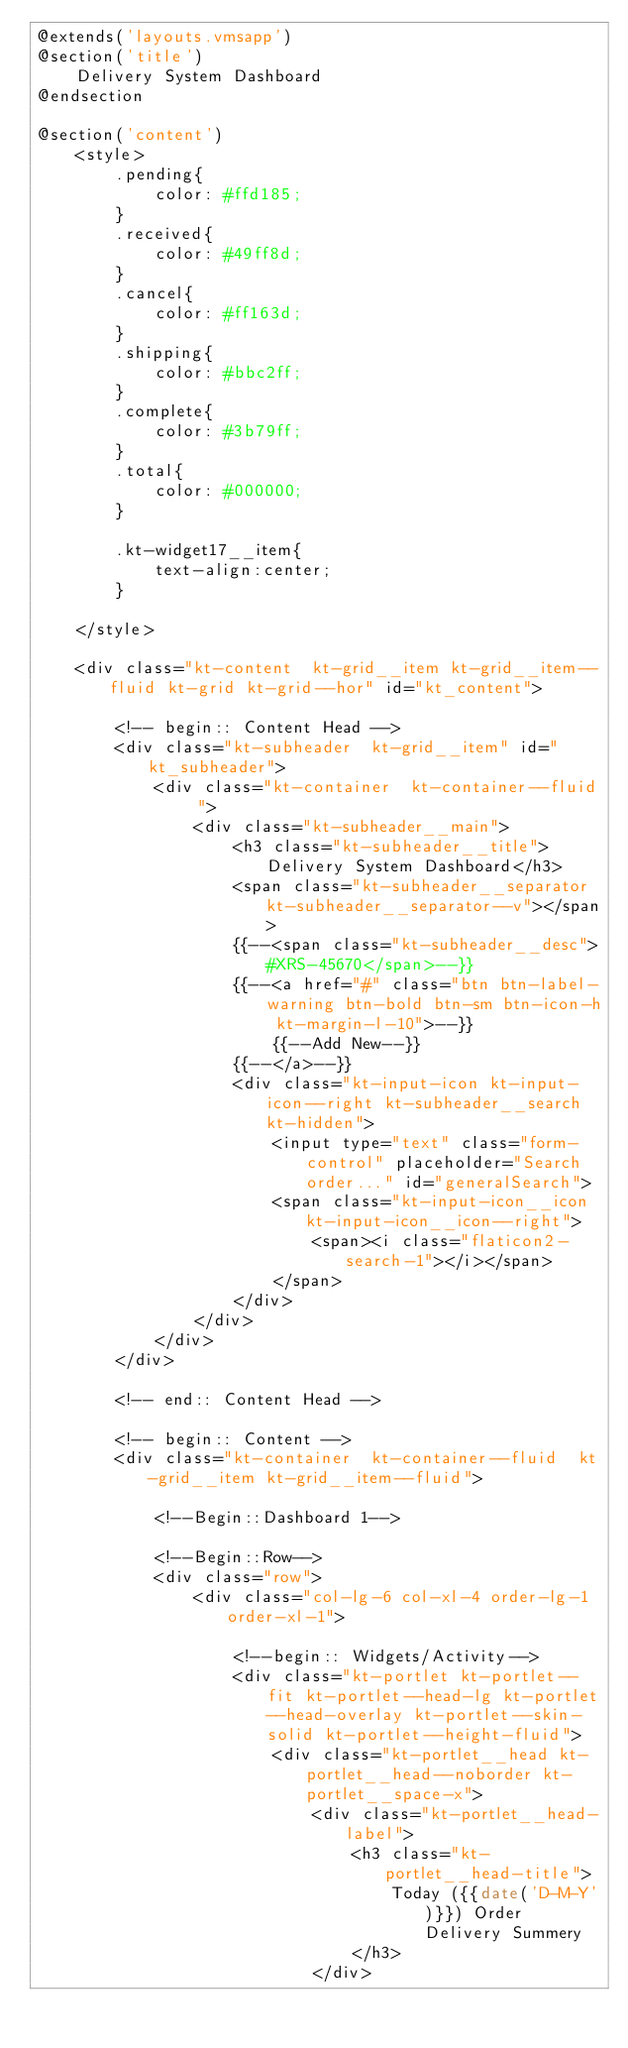<code> <loc_0><loc_0><loc_500><loc_500><_PHP_>@extends('layouts.vmsapp')
@section('title')
    Delivery System Dashboard
@endsection

@section('content')
    <style>
        .pending{
            color: #ffd185;
        }
        .received{
            color: #49ff8d;
        }
        .cancel{
            color: #ff163d;
        }
        .shipping{
            color: #bbc2ff;
        }
        .complete{
            color: #3b79ff;
        }
        .total{
            color: #000000;
        }

        .kt-widget17__item{
            text-align:center;
        }

    </style>

    <div class="kt-content  kt-grid__item kt-grid__item--fluid kt-grid kt-grid--hor" id="kt_content">

        <!-- begin:: Content Head -->
        <div class="kt-subheader  kt-grid__item" id="kt_subheader">
            <div class="kt-container  kt-container--fluid ">
                <div class="kt-subheader__main">
                    <h3 class="kt-subheader__title">   Delivery System Dashboard</h3>
                    <span class="kt-subheader__separator kt-subheader__separator--v"></span>
                    {{--<span class="kt-subheader__desc">#XRS-45670</span>--}}
                    {{--<a href="#" class="btn btn-label-warning btn-bold btn-sm btn-icon-h kt-margin-l-10">--}}
                        {{--Add New--}}
                    {{--</a>--}}
                    <div class="kt-input-icon kt-input-icon--right kt-subheader__search kt-hidden">
                        <input type="text" class="form-control" placeholder="Search order..." id="generalSearch">
                        <span class="kt-input-icon__icon kt-input-icon__icon--right">
                            <span><i class="flaticon2-search-1"></i></span>
                        </span>
                    </div>
                </div>
            </div>
        </div>

        <!-- end:: Content Head -->

        <!-- begin:: Content -->
        <div class="kt-container  kt-container--fluid  kt-grid__item kt-grid__item--fluid">

            <!--Begin::Dashboard 1-->

            <!--Begin::Row-->
            <div class="row">
                <div class="col-lg-6 col-xl-4 order-lg-1 order-xl-1">

                    <!--begin:: Widgets/Activity-->
                    <div class="kt-portlet kt-portlet--fit kt-portlet--head-lg kt-portlet--head-overlay kt-portlet--skin-solid kt-portlet--height-fluid">
                        <div class="kt-portlet__head kt-portlet__head--noborder kt-portlet__space-x">
                            <div class="kt-portlet__head-label">
                                <h3 class="kt-portlet__head-title">
                                    Today ({{date('D-M-Y')}}) Order Delivery Summery
                                </h3>
                            </div></code> 